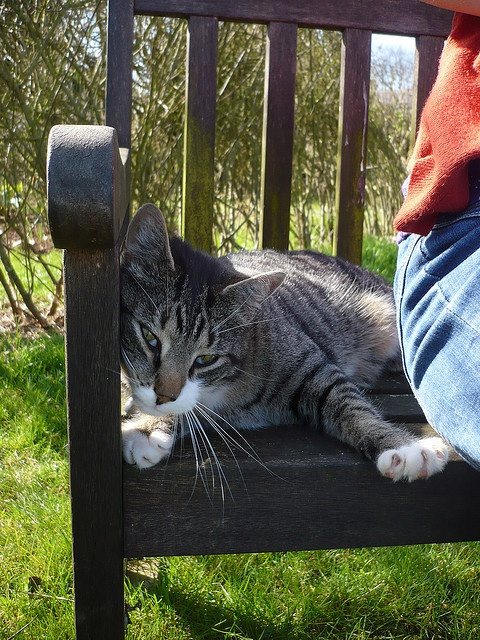Describe the objects in this image and their specific colors. I can see chair in black, darkgreen, gray, and olive tones, bench in black, darkgreen, gray, and olive tones, cat in black, gray, darkgray, and lightgray tones, and people in black, lightblue, navy, and maroon tones in this image. 